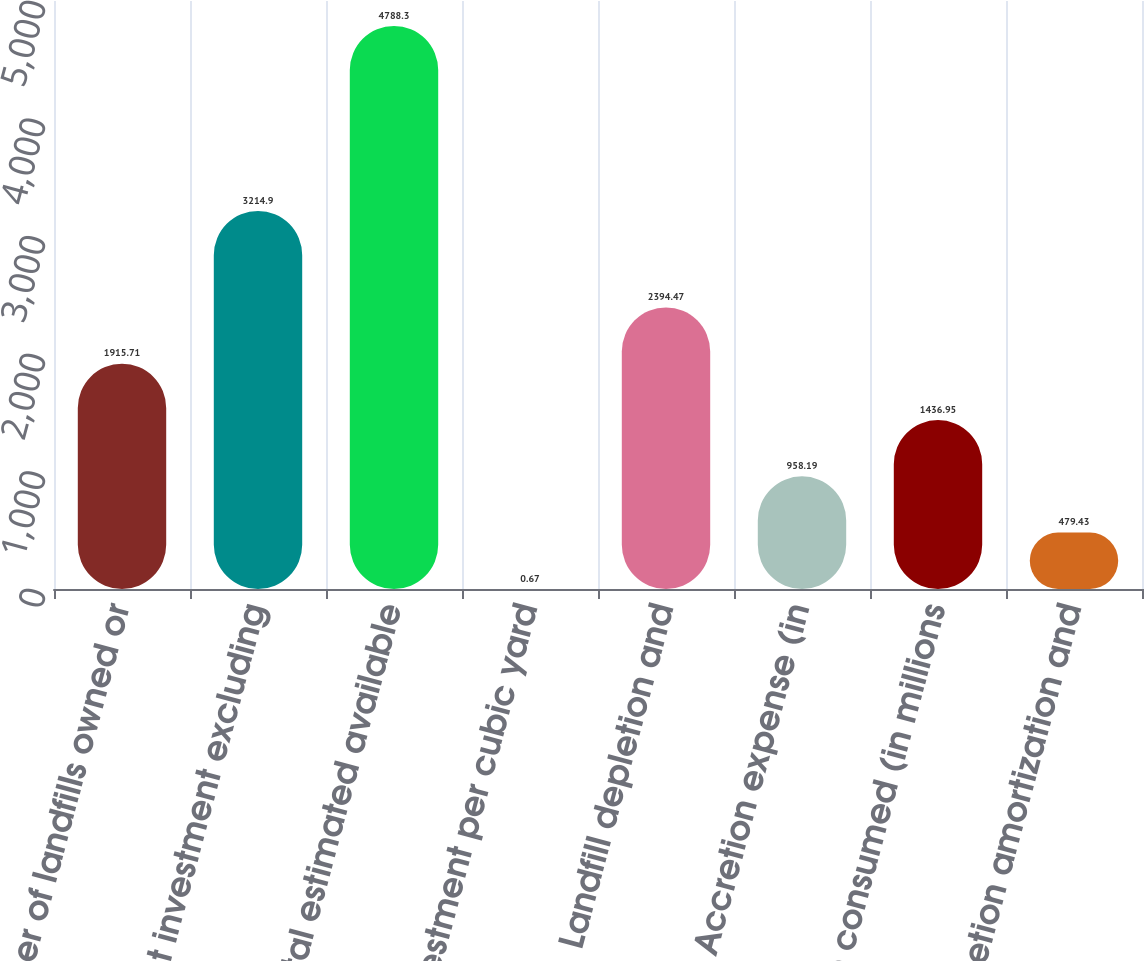<chart> <loc_0><loc_0><loc_500><loc_500><bar_chart><fcel>Number of landfills owned or<fcel>Net investment excluding<fcel>Total estimated available<fcel>Net investment per cubic yard<fcel>Landfill depletion and<fcel>Accretion expense (in<fcel>Airspace consumed (in millions<fcel>Depletion amortization and<nl><fcel>1915.71<fcel>3214.9<fcel>4788.3<fcel>0.67<fcel>2394.47<fcel>958.19<fcel>1436.95<fcel>479.43<nl></chart> 